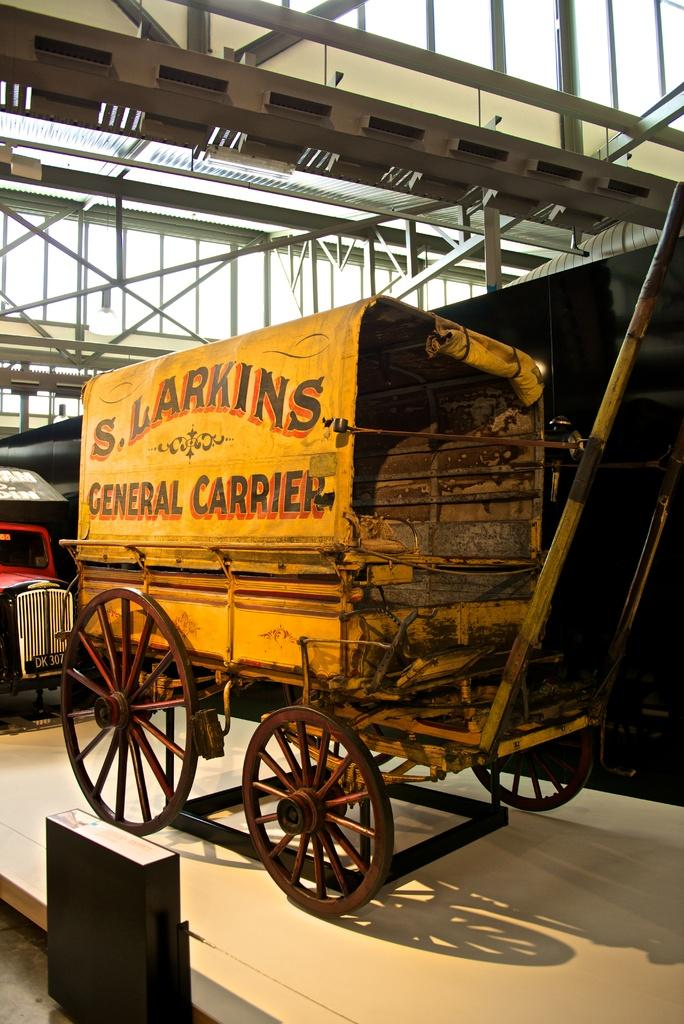What is the main subject in the center of the image? There is a vehicle in the center of the image. Where is the vehicle located? The vehicle is on the floor. What can be seen in the background of the image? There are poles, windows, lights, and a wall in the background of the image. What type of ink is being used to draw on the vehicle in the image? There is no ink or drawing present on the vehicle in the image. How many chairs are visible in the image? There are no chairs visible in the image; it only features a vehicle and background elements. 